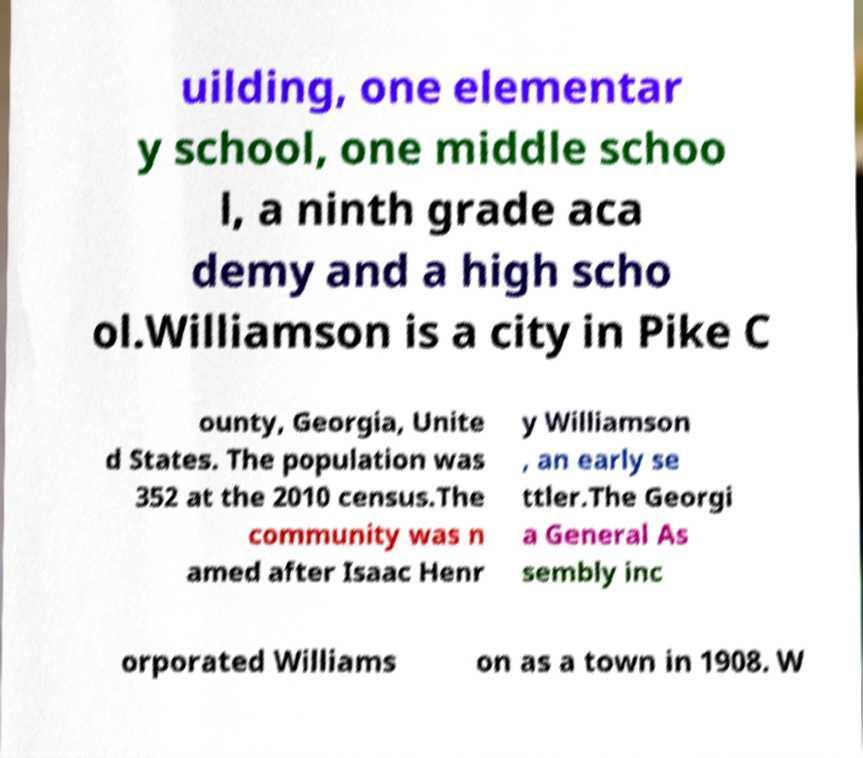Can you read and provide the text displayed in the image?This photo seems to have some interesting text. Can you extract and type it out for me? uilding, one elementar y school, one middle schoo l, a ninth grade aca demy and a high scho ol.Williamson is a city in Pike C ounty, Georgia, Unite d States. The population was 352 at the 2010 census.The community was n amed after Isaac Henr y Williamson , an early se ttler.The Georgi a General As sembly inc orporated Williams on as a town in 1908. W 